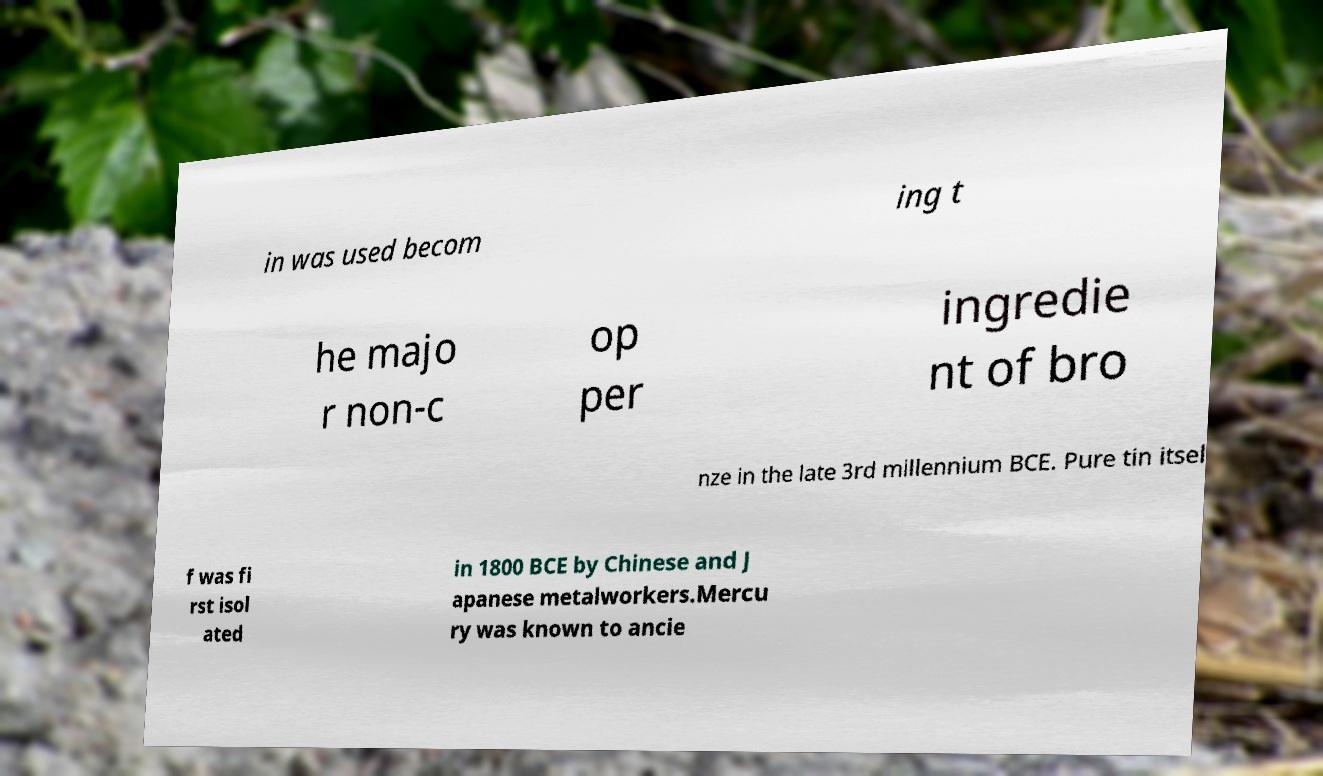Can you accurately transcribe the text from the provided image for me? in was used becom ing t he majo r non-c op per ingredie nt of bro nze in the late 3rd millennium BCE. Pure tin itsel f was fi rst isol ated in 1800 BCE by Chinese and J apanese metalworkers.Mercu ry was known to ancie 